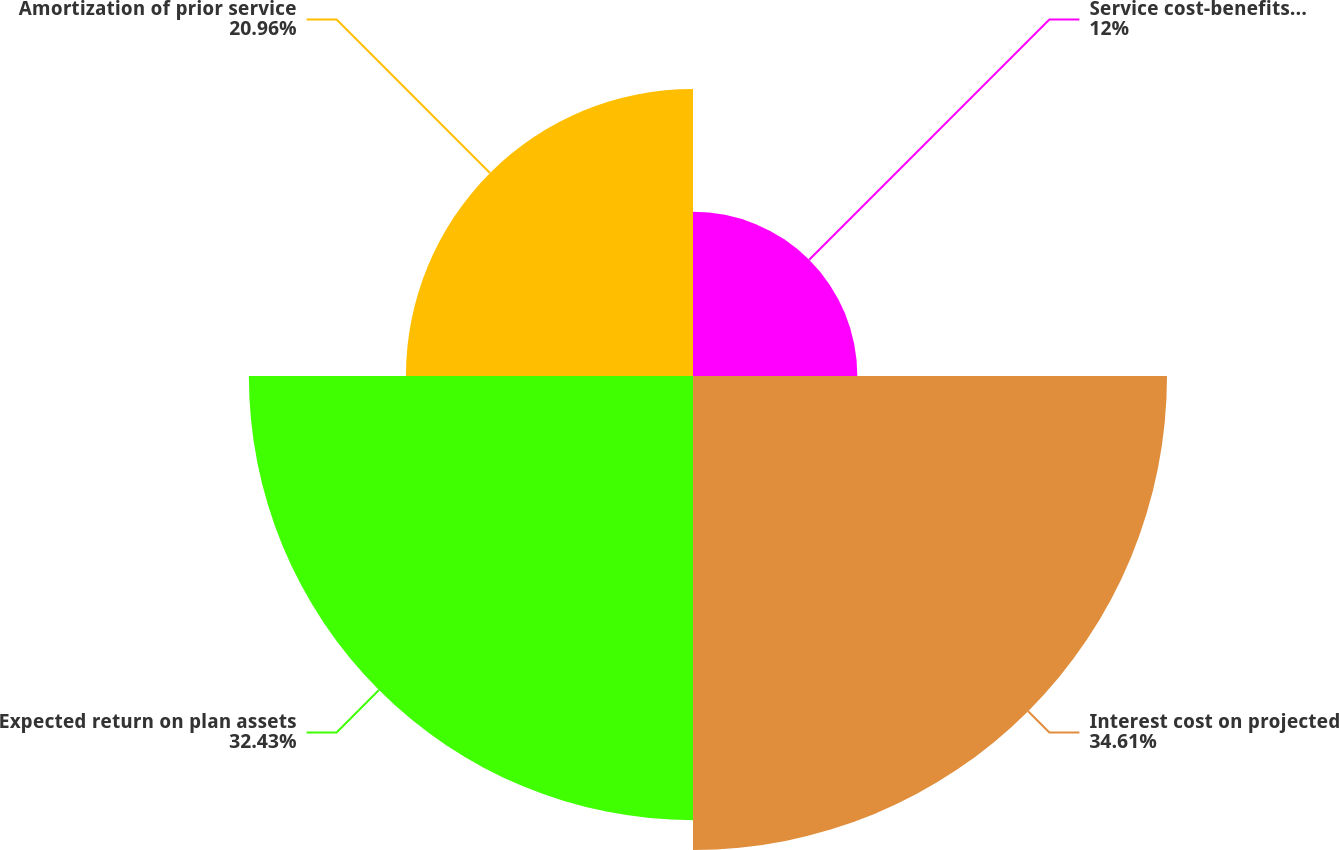Convert chart to OTSL. <chart><loc_0><loc_0><loc_500><loc_500><pie_chart><fcel>Service cost-benefits earned<fcel>Interest cost on projected<fcel>Expected return on plan assets<fcel>Amortization of prior service<nl><fcel>12.0%<fcel>34.61%<fcel>32.43%<fcel>20.96%<nl></chart> 